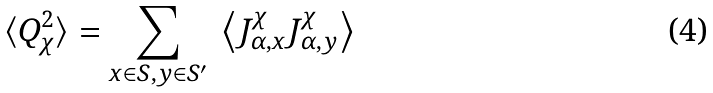Convert formula to latex. <formula><loc_0><loc_0><loc_500><loc_500>\langle Q _ { \chi } ^ { 2 } \rangle = \sum _ { x \in S , y \in S ^ { \prime } } \ \left \langle J ^ { \chi } _ { \alpha , x } J ^ { \chi } _ { \alpha , y } \right \rangle</formula> 